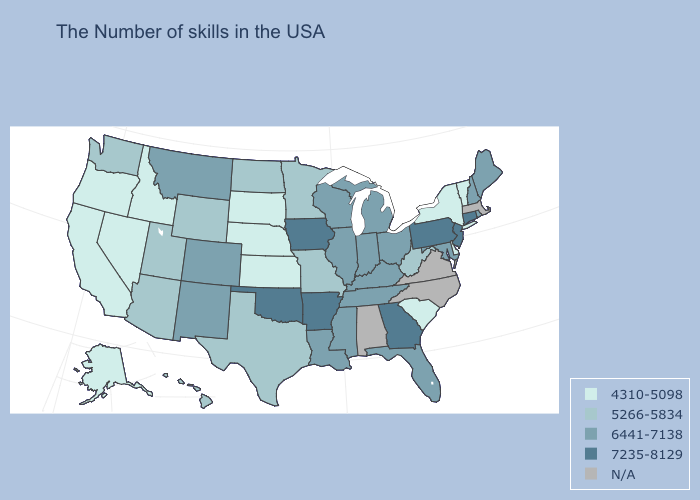What is the lowest value in the West?
Concise answer only. 4310-5098. Which states have the highest value in the USA?
Quick response, please. Connecticut, New Jersey, Pennsylvania, Georgia, Arkansas, Iowa, Oklahoma. Name the states that have a value in the range N/A?
Keep it brief. Massachusetts, Virginia, North Carolina, Alabama. What is the highest value in states that border Delaware?
Give a very brief answer. 7235-8129. What is the lowest value in the MidWest?
Give a very brief answer. 4310-5098. What is the value of Kentucky?
Give a very brief answer. 6441-7138. What is the value of Maine?
Short answer required. 6441-7138. What is the highest value in the West ?
Concise answer only. 6441-7138. Name the states that have a value in the range N/A?
Quick response, please. Massachusetts, Virginia, North Carolina, Alabama. What is the lowest value in the USA?
Concise answer only. 4310-5098. Name the states that have a value in the range N/A?
Write a very short answer. Massachusetts, Virginia, North Carolina, Alabama. Does the map have missing data?
Give a very brief answer. Yes. Does Iowa have the highest value in the MidWest?
Concise answer only. Yes. Name the states that have a value in the range 7235-8129?
Answer briefly. Connecticut, New Jersey, Pennsylvania, Georgia, Arkansas, Iowa, Oklahoma. 